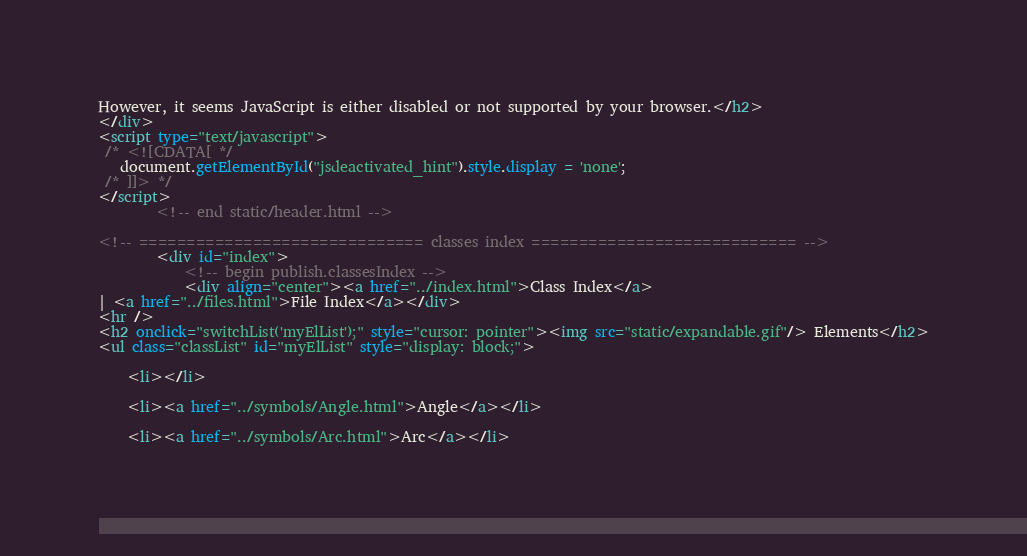<code> <loc_0><loc_0><loc_500><loc_500><_HTML_>However, it seems JavaScript is either disabled or not supported by your browser.</h2>
</div>
<script type="text/javascript">
 /* <![CDATA[ */
   document.getElementById("jsdeactivated_hint").style.display = 'none';
 /* ]]> */
</script>
		<!-- end static/header.html -->

<!-- ============================== classes index ============================ -->
		<div id="index">
			<!-- begin publish.classesIndex -->
			<div align="center"><a href="../index.html">Class Index</a>
| <a href="../files.html">File Index</a></div>
<hr />
<h2 onclick="switchList('myElList');" style="cursor: pointer"><img src="static/expandable.gif"/> Elements</h2>
<ul class="classList" id="myElList" style="display: block;">
	
	<li></li>
	
	<li><a href="../symbols/Angle.html">Angle</a></li>
	
	<li><a href="../symbols/Arc.html">Arc</a></li>
	</code> 